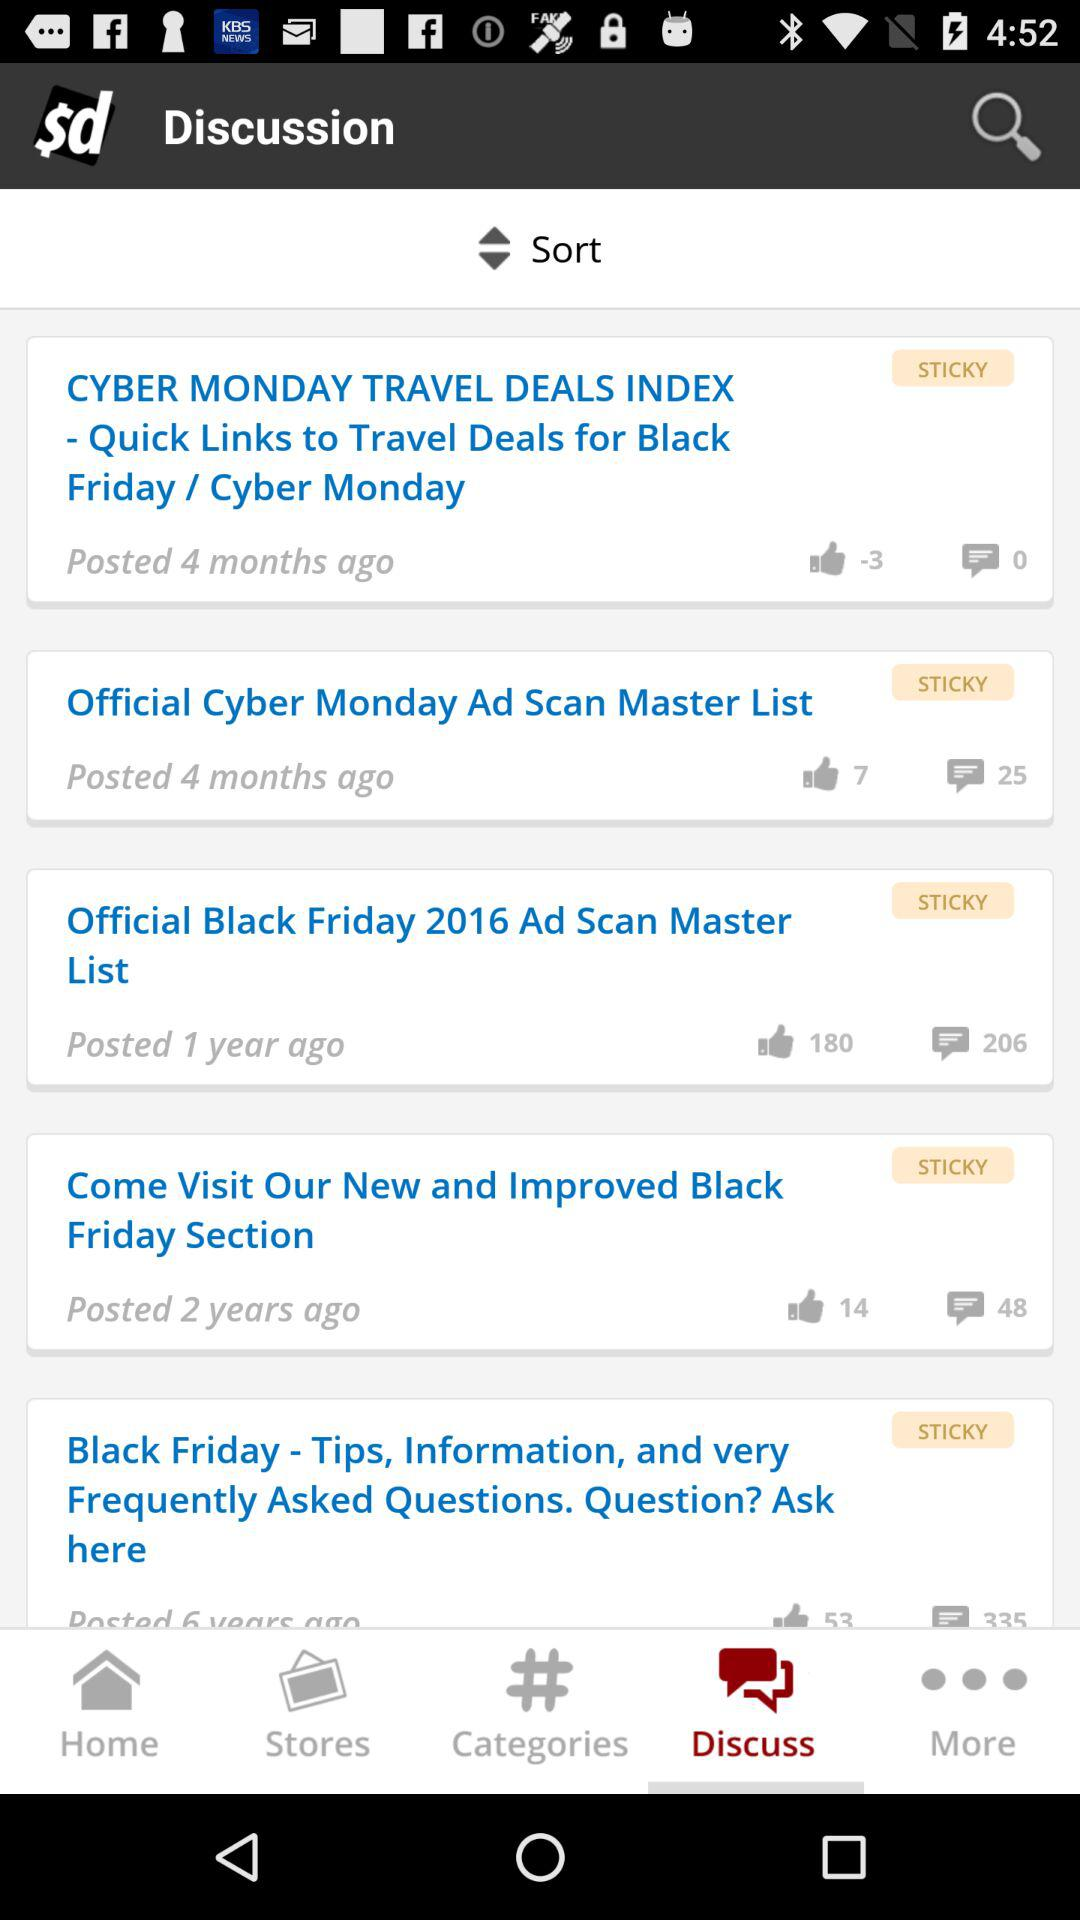How many likes are there for "Come Visit Our New and Improved Black Friday Section"? There are 14 likes. 